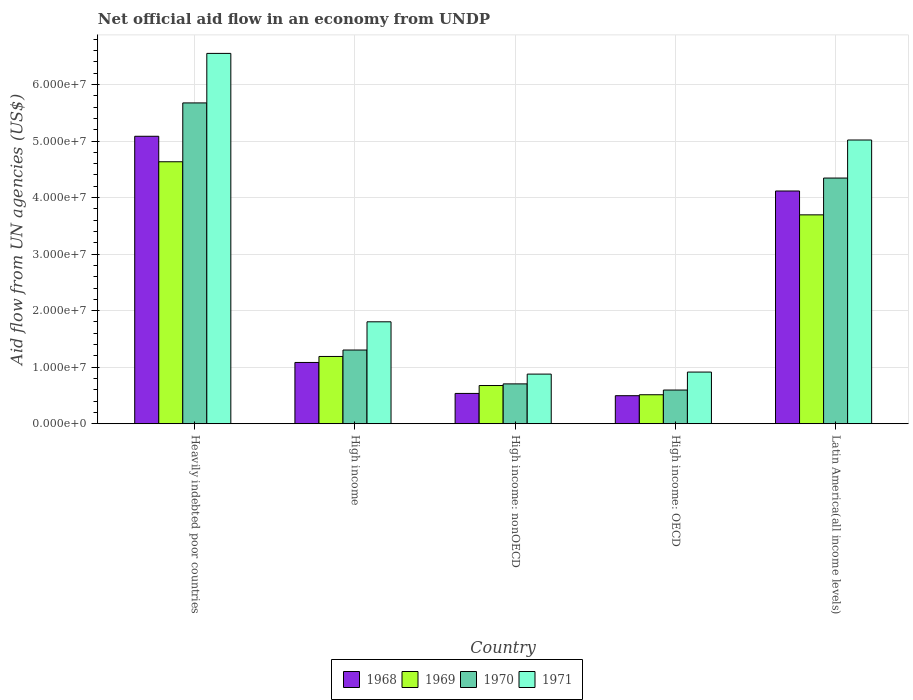How many different coloured bars are there?
Provide a short and direct response. 4. Are the number of bars per tick equal to the number of legend labels?
Offer a terse response. Yes. How many bars are there on the 4th tick from the left?
Make the answer very short. 4. What is the label of the 3rd group of bars from the left?
Your response must be concise. High income: nonOECD. In how many cases, is the number of bars for a given country not equal to the number of legend labels?
Provide a succinct answer. 0. What is the net official aid flow in 1969 in Heavily indebted poor countries?
Give a very brief answer. 4.63e+07. Across all countries, what is the maximum net official aid flow in 1971?
Give a very brief answer. 6.55e+07. Across all countries, what is the minimum net official aid flow in 1970?
Make the answer very short. 5.96e+06. In which country was the net official aid flow in 1969 maximum?
Your answer should be very brief. Heavily indebted poor countries. In which country was the net official aid flow in 1970 minimum?
Your answer should be compact. High income: OECD. What is the total net official aid flow in 1971 in the graph?
Your response must be concise. 1.52e+08. What is the difference between the net official aid flow in 1969 in Heavily indebted poor countries and that in Latin America(all income levels)?
Your response must be concise. 9.39e+06. What is the difference between the net official aid flow in 1969 in Latin America(all income levels) and the net official aid flow in 1968 in Heavily indebted poor countries?
Your response must be concise. -1.39e+07. What is the average net official aid flow in 1971 per country?
Your answer should be very brief. 3.03e+07. What is the difference between the net official aid flow of/in 1971 and net official aid flow of/in 1969 in Heavily indebted poor countries?
Ensure brevity in your answer.  1.92e+07. In how many countries, is the net official aid flow in 1968 greater than 42000000 US$?
Offer a very short reply. 1. What is the ratio of the net official aid flow in 1971 in High income to that in High income: OECD?
Make the answer very short. 1.97. What is the difference between the highest and the second highest net official aid flow in 1969?
Keep it short and to the point. 3.44e+07. What is the difference between the highest and the lowest net official aid flow in 1970?
Provide a succinct answer. 5.08e+07. Is the sum of the net official aid flow in 1968 in High income: nonOECD and Latin America(all income levels) greater than the maximum net official aid flow in 1969 across all countries?
Your answer should be very brief. Yes. Is it the case that in every country, the sum of the net official aid flow in 1969 and net official aid flow in 1971 is greater than the sum of net official aid flow in 1970 and net official aid flow in 1968?
Give a very brief answer. No. What does the 1st bar from the left in High income represents?
Your answer should be very brief. 1968. What does the 4th bar from the right in Latin America(all income levels) represents?
Provide a short and direct response. 1968. How many bars are there?
Provide a succinct answer. 20. What is the difference between two consecutive major ticks on the Y-axis?
Give a very brief answer. 1.00e+07. Where does the legend appear in the graph?
Provide a short and direct response. Bottom center. What is the title of the graph?
Your answer should be compact. Net official aid flow in an economy from UNDP. What is the label or title of the X-axis?
Provide a short and direct response. Country. What is the label or title of the Y-axis?
Offer a terse response. Aid flow from UN agencies (US$). What is the Aid flow from UN agencies (US$) of 1968 in Heavily indebted poor countries?
Your answer should be very brief. 5.08e+07. What is the Aid flow from UN agencies (US$) in 1969 in Heavily indebted poor countries?
Make the answer very short. 4.63e+07. What is the Aid flow from UN agencies (US$) in 1970 in Heavily indebted poor countries?
Your response must be concise. 5.68e+07. What is the Aid flow from UN agencies (US$) in 1971 in Heavily indebted poor countries?
Give a very brief answer. 6.55e+07. What is the Aid flow from UN agencies (US$) of 1968 in High income?
Ensure brevity in your answer.  1.08e+07. What is the Aid flow from UN agencies (US$) of 1969 in High income?
Offer a very short reply. 1.19e+07. What is the Aid flow from UN agencies (US$) in 1970 in High income?
Your answer should be very brief. 1.30e+07. What is the Aid flow from UN agencies (US$) in 1971 in High income?
Provide a succinct answer. 1.80e+07. What is the Aid flow from UN agencies (US$) of 1968 in High income: nonOECD?
Ensure brevity in your answer.  5.36e+06. What is the Aid flow from UN agencies (US$) in 1969 in High income: nonOECD?
Keep it short and to the point. 6.76e+06. What is the Aid flow from UN agencies (US$) of 1970 in High income: nonOECD?
Your answer should be very brief. 7.05e+06. What is the Aid flow from UN agencies (US$) of 1971 in High income: nonOECD?
Your response must be concise. 8.78e+06. What is the Aid flow from UN agencies (US$) in 1968 in High income: OECD?
Keep it short and to the point. 4.96e+06. What is the Aid flow from UN agencies (US$) of 1969 in High income: OECD?
Ensure brevity in your answer.  5.13e+06. What is the Aid flow from UN agencies (US$) of 1970 in High income: OECD?
Offer a terse response. 5.96e+06. What is the Aid flow from UN agencies (US$) of 1971 in High income: OECD?
Provide a short and direct response. 9.14e+06. What is the Aid flow from UN agencies (US$) of 1968 in Latin America(all income levels)?
Give a very brief answer. 4.12e+07. What is the Aid flow from UN agencies (US$) in 1969 in Latin America(all income levels)?
Provide a short and direct response. 3.70e+07. What is the Aid flow from UN agencies (US$) of 1970 in Latin America(all income levels)?
Keep it short and to the point. 4.35e+07. What is the Aid flow from UN agencies (US$) of 1971 in Latin America(all income levels)?
Your response must be concise. 5.02e+07. Across all countries, what is the maximum Aid flow from UN agencies (US$) of 1968?
Keep it short and to the point. 5.08e+07. Across all countries, what is the maximum Aid flow from UN agencies (US$) in 1969?
Give a very brief answer. 4.63e+07. Across all countries, what is the maximum Aid flow from UN agencies (US$) in 1970?
Your answer should be very brief. 5.68e+07. Across all countries, what is the maximum Aid flow from UN agencies (US$) of 1971?
Your answer should be compact. 6.55e+07. Across all countries, what is the minimum Aid flow from UN agencies (US$) of 1968?
Ensure brevity in your answer.  4.96e+06. Across all countries, what is the minimum Aid flow from UN agencies (US$) of 1969?
Your response must be concise. 5.13e+06. Across all countries, what is the minimum Aid flow from UN agencies (US$) of 1970?
Your answer should be very brief. 5.96e+06. Across all countries, what is the minimum Aid flow from UN agencies (US$) in 1971?
Give a very brief answer. 8.78e+06. What is the total Aid flow from UN agencies (US$) of 1968 in the graph?
Your answer should be compact. 1.13e+08. What is the total Aid flow from UN agencies (US$) of 1969 in the graph?
Provide a succinct answer. 1.07e+08. What is the total Aid flow from UN agencies (US$) in 1970 in the graph?
Keep it short and to the point. 1.26e+08. What is the total Aid flow from UN agencies (US$) in 1971 in the graph?
Ensure brevity in your answer.  1.52e+08. What is the difference between the Aid flow from UN agencies (US$) in 1968 in Heavily indebted poor countries and that in High income?
Keep it short and to the point. 4.00e+07. What is the difference between the Aid flow from UN agencies (US$) of 1969 in Heavily indebted poor countries and that in High income?
Give a very brief answer. 3.44e+07. What is the difference between the Aid flow from UN agencies (US$) in 1970 in Heavily indebted poor countries and that in High income?
Provide a succinct answer. 4.37e+07. What is the difference between the Aid flow from UN agencies (US$) of 1971 in Heavily indebted poor countries and that in High income?
Your response must be concise. 4.75e+07. What is the difference between the Aid flow from UN agencies (US$) of 1968 in Heavily indebted poor countries and that in High income: nonOECD?
Your answer should be very brief. 4.55e+07. What is the difference between the Aid flow from UN agencies (US$) in 1969 in Heavily indebted poor countries and that in High income: nonOECD?
Make the answer very short. 3.96e+07. What is the difference between the Aid flow from UN agencies (US$) in 1970 in Heavily indebted poor countries and that in High income: nonOECD?
Offer a very short reply. 4.97e+07. What is the difference between the Aid flow from UN agencies (US$) of 1971 in Heavily indebted poor countries and that in High income: nonOECD?
Make the answer very short. 5.67e+07. What is the difference between the Aid flow from UN agencies (US$) of 1968 in Heavily indebted poor countries and that in High income: OECD?
Your response must be concise. 4.59e+07. What is the difference between the Aid flow from UN agencies (US$) of 1969 in Heavily indebted poor countries and that in High income: OECD?
Offer a terse response. 4.12e+07. What is the difference between the Aid flow from UN agencies (US$) in 1970 in Heavily indebted poor countries and that in High income: OECD?
Your answer should be compact. 5.08e+07. What is the difference between the Aid flow from UN agencies (US$) in 1971 in Heavily indebted poor countries and that in High income: OECD?
Your answer should be very brief. 5.64e+07. What is the difference between the Aid flow from UN agencies (US$) of 1968 in Heavily indebted poor countries and that in Latin America(all income levels)?
Offer a terse response. 9.68e+06. What is the difference between the Aid flow from UN agencies (US$) of 1969 in Heavily indebted poor countries and that in Latin America(all income levels)?
Keep it short and to the point. 9.39e+06. What is the difference between the Aid flow from UN agencies (US$) in 1970 in Heavily indebted poor countries and that in Latin America(all income levels)?
Keep it short and to the point. 1.33e+07. What is the difference between the Aid flow from UN agencies (US$) of 1971 in Heavily indebted poor countries and that in Latin America(all income levels)?
Ensure brevity in your answer.  1.53e+07. What is the difference between the Aid flow from UN agencies (US$) in 1968 in High income and that in High income: nonOECD?
Make the answer very short. 5.48e+06. What is the difference between the Aid flow from UN agencies (US$) in 1969 in High income and that in High income: nonOECD?
Offer a very short reply. 5.14e+06. What is the difference between the Aid flow from UN agencies (US$) of 1970 in High income and that in High income: nonOECD?
Your answer should be compact. 5.99e+06. What is the difference between the Aid flow from UN agencies (US$) in 1971 in High income and that in High income: nonOECD?
Provide a short and direct response. 9.25e+06. What is the difference between the Aid flow from UN agencies (US$) in 1968 in High income and that in High income: OECD?
Your answer should be compact. 5.88e+06. What is the difference between the Aid flow from UN agencies (US$) of 1969 in High income and that in High income: OECD?
Make the answer very short. 6.77e+06. What is the difference between the Aid flow from UN agencies (US$) in 1970 in High income and that in High income: OECD?
Give a very brief answer. 7.08e+06. What is the difference between the Aid flow from UN agencies (US$) of 1971 in High income and that in High income: OECD?
Your response must be concise. 8.89e+06. What is the difference between the Aid flow from UN agencies (US$) of 1968 in High income and that in Latin America(all income levels)?
Provide a short and direct response. -3.03e+07. What is the difference between the Aid flow from UN agencies (US$) of 1969 in High income and that in Latin America(all income levels)?
Keep it short and to the point. -2.50e+07. What is the difference between the Aid flow from UN agencies (US$) in 1970 in High income and that in Latin America(all income levels)?
Offer a terse response. -3.04e+07. What is the difference between the Aid flow from UN agencies (US$) in 1971 in High income and that in Latin America(all income levels)?
Keep it short and to the point. -3.22e+07. What is the difference between the Aid flow from UN agencies (US$) of 1969 in High income: nonOECD and that in High income: OECD?
Provide a succinct answer. 1.63e+06. What is the difference between the Aid flow from UN agencies (US$) of 1970 in High income: nonOECD and that in High income: OECD?
Your answer should be very brief. 1.09e+06. What is the difference between the Aid flow from UN agencies (US$) of 1971 in High income: nonOECD and that in High income: OECD?
Offer a very short reply. -3.60e+05. What is the difference between the Aid flow from UN agencies (US$) in 1968 in High income: nonOECD and that in Latin America(all income levels)?
Your answer should be compact. -3.58e+07. What is the difference between the Aid flow from UN agencies (US$) in 1969 in High income: nonOECD and that in Latin America(all income levels)?
Keep it short and to the point. -3.02e+07. What is the difference between the Aid flow from UN agencies (US$) in 1970 in High income: nonOECD and that in Latin America(all income levels)?
Give a very brief answer. -3.64e+07. What is the difference between the Aid flow from UN agencies (US$) in 1971 in High income: nonOECD and that in Latin America(all income levels)?
Offer a terse response. -4.14e+07. What is the difference between the Aid flow from UN agencies (US$) in 1968 in High income: OECD and that in Latin America(all income levels)?
Offer a terse response. -3.62e+07. What is the difference between the Aid flow from UN agencies (US$) of 1969 in High income: OECD and that in Latin America(all income levels)?
Your answer should be very brief. -3.18e+07. What is the difference between the Aid flow from UN agencies (US$) in 1970 in High income: OECD and that in Latin America(all income levels)?
Provide a succinct answer. -3.75e+07. What is the difference between the Aid flow from UN agencies (US$) in 1971 in High income: OECD and that in Latin America(all income levels)?
Your answer should be very brief. -4.10e+07. What is the difference between the Aid flow from UN agencies (US$) of 1968 in Heavily indebted poor countries and the Aid flow from UN agencies (US$) of 1969 in High income?
Provide a short and direct response. 3.90e+07. What is the difference between the Aid flow from UN agencies (US$) of 1968 in Heavily indebted poor countries and the Aid flow from UN agencies (US$) of 1970 in High income?
Keep it short and to the point. 3.78e+07. What is the difference between the Aid flow from UN agencies (US$) of 1968 in Heavily indebted poor countries and the Aid flow from UN agencies (US$) of 1971 in High income?
Keep it short and to the point. 3.28e+07. What is the difference between the Aid flow from UN agencies (US$) of 1969 in Heavily indebted poor countries and the Aid flow from UN agencies (US$) of 1970 in High income?
Your answer should be compact. 3.33e+07. What is the difference between the Aid flow from UN agencies (US$) of 1969 in Heavily indebted poor countries and the Aid flow from UN agencies (US$) of 1971 in High income?
Your answer should be compact. 2.83e+07. What is the difference between the Aid flow from UN agencies (US$) in 1970 in Heavily indebted poor countries and the Aid flow from UN agencies (US$) in 1971 in High income?
Offer a terse response. 3.87e+07. What is the difference between the Aid flow from UN agencies (US$) of 1968 in Heavily indebted poor countries and the Aid flow from UN agencies (US$) of 1969 in High income: nonOECD?
Ensure brevity in your answer.  4.41e+07. What is the difference between the Aid flow from UN agencies (US$) in 1968 in Heavily indebted poor countries and the Aid flow from UN agencies (US$) in 1970 in High income: nonOECD?
Keep it short and to the point. 4.38e+07. What is the difference between the Aid flow from UN agencies (US$) in 1968 in Heavily indebted poor countries and the Aid flow from UN agencies (US$) in 1971 in High income: nonOECD?
Your answer should be very brief. 4.21e+07. What is the difference between the Aid flow from UN agencies (US$) of 1969 in Heavily indebted poor countries and the Aid flow from UN agencies (US$) of 1970 in High income: nonOECD?
Ensure brevity in your answer.  3.93e+07. What is the difference between the Aid flow from UN agencies (US$) in 1969 in Heavily indebted poor countries and the Aid flow from UN agencies (US$) in 1971 in High income: nonOECD?
Your answer should be very brief. 3.76e+07. What is the difference between the Aid flow from UN agencies (US$) of 1970 in Heavily indebted poor countries and the Aid flow from UN agencies (US$) of 1971 in High income: nonOECD?
Your answer should be very brief. 4.80e+07. What is the difference between the Aid flow from UN agencies (US$) in 1968 in Heavily indebted poor countries and the Aid flow from UN agencies (US$) in 1969 in High income: OECD?
Offer a terse response. 4.57e+07. What is the difference between the Aid flow from UN agencies (US$) of 1968 in Heavily indebted poor countries and the Aid flow from UN agencies (US$) of 1970 in High income: OECD?
Provide a short and direct response. 4.49e+07. What is the difference between the Aid flow from UN agencies (US$) in 1968 in Heavily indebted poor countries and the Aid flow from UN agencies (US$) in 1971 in High income: OECD?
Offer a very short reply. 4.17e+07. What is the difference between the Aid flow from UN agencies (US$) of 1969 in Heavily indebted poor countries and the Aid flow from UN agencies (US$) of 1970 in High income: OECD?
Provide a short and direct response. 4.04e+07. What is the difference between the Aid flow from UN agencies (US$) in 1969 in Heavily indebted poor countries and the Aid flow from UN agencies (US$) in 1971 in High income: OECD?
Make the answer very short. 3.72e+07. What is the difference between the Aid flow from UN agencies (US$) of 1970 in Heavily indebted poor countries and the Aid flow from UN agencies (US$) of 1971 in High income: OECD?
Your response must be concise. 4.76e+07. What is the difference between the Aid flow from UN agencies (US$) in 1968 in Heavily indebted poor countries and the Aid flow from UN agencies (US$) in 1969 in Latin America(all income levels)?
Your answer should be very brief. 1.39e+07. What is the difference between the Aid flow from UN agencies (US$) of 1968 in Heavily indebted poor countries and the Aid flow from UN agencies (US$) of 1970 in Latin America(all income levels)?
Provide a short and direct response. 7.39e+06. What is the difference between the Aid flow from UN agencies (US$) in 1969 in Heavily indebted poor countries and the Aid flow from UN agencies (US$) in 1970 in Latin America(all income levels)?
Keep it short and to the point. 2.88e+06. What is the difference between the Aid flow from UN agencies (US$) of 1969 in Heavily indebted poor countries and the Aid flow from UN agencies (US$) of 1971 in Latin America(all income levels)?
Keep it short and to the point. -3.85e+06. What is the difference between the Aid flow from UN agencies (US$) of 1970 in Heavily indebted poor countries and the Aid flow from UN agencies (US$) of 1971 in Latin America(all income levels)?
Your response must be concise. 6.56e+06. What is the difference between the Aid flow from UN agencies (US$) in 1968 in High income and the Aid flow from UN agencies (US$) in 1969 in High income: nonOECD?
Your response must be concise. 4.08e+06. What is the difference between the Aid flow from UN agencies (US$) of 1968 in High income and the Aid flow from UN agencies (US$) of 1970 in High income: nonOECD?
Make the answer very short. 3.79e+06. What is the difference between the Aid flow from UN agencies (US$) in 1968 in High income and the Aid flow from UN agencies (US$) in 1971 in High income: nonOECD?
Your answer should be compact. 2.06e+06. What is the difference between the Aid flow from UN agencies (US$) of 1969 in High income and the Aid flow from UN agencies (US$) of 1970 in High income: nonOECD?
Make the answer very short. 4.85e+06. What is the difference between the Aid flow from UN agencies (US$) in 1969 in High income and the Aid flow from UN agencies (US$) in 1971 in High income: nonOECD?
Ensure brevity in your answer.  3.12e+06. What is the difference between the Aid flow from UN agencies (US$) of 1970 in High income and the Aid flow from UN agencies (US$) of 1971 in High income: nonOECD?
Make the answer very short. 4.26e+06. What is the difference between the Aid flow from UN agencies (US$) of 1968 in High income and the Aid flow from UN agencies (US$) of 1969 in High income: OECD?
Provide a succinct answer. 5.71e+06. What is the difference between the Aid flow from UN agencies (US$) of 1968 in High income and the Aid flow from UN agencies (US$) of 1970 in High income: OECD?
Provide a short and direct response. 4.88e+06. What is the difference between the Aid flow from UN agencies (US$) of 1968 in High income and the Aid flow from UN agencies (US$) of 1971 in High income: OECD?
Your answer should be compact. 1.70e+06. What is the difference between the Aid flow from UN agencies (US$) of 1969 in High income and the Aid flow from UN agencies (US$) of 1970 in High income: OECD?
Make the answer very short. 5.94e+06. What is the difference between the Aid flow from UN agencies (US$) in 1969 in High income and the Aid flow from UN agencies (US$) in 1971 in High income: OECD?
Offer a very short reply. 2.76e+06. What is the difference between the Aid flow from UN agencies (US$) of 1970 in High income and the Aid flow from UN agencies (US$) of 1971 in High income: OECD?
Offer a very short reply. 3.90e+06. What is the difference between the Aid flow from UN agencies (US$) in 1968 in High income and the Aid flow from UN agencies (US$) in 1969 in Latin America(all income levels)?
Keep it short and to the point. -2.61e+07. What is the difference between the Aid flow from UN agencies (US$) in 1968 in High income and the Aid flow from UN agencies (US$) in 1970 in Latin America(all income levels)?
Offer a very short reply. -3.26e+07. What is the difference between the Aid flow from UN agencies (US$) of 1968 in High income and the Aid flow from UN agencies (US$) of 1971 in Latin America(all income levels)?
Your response must be concise. -3.94e+07. What is the difference between the Aid flow from UN agencies (US$) of 1969 in High income and the Aid flow from UN agencies (US$) of 1970 in Latin America(all income levels)?
Offer a terse response. -3.16e+07. What is the difference between the Aid flow from UN agencies (US$) in 1969 in High income and the Aid flow from UN agencies (US$) in 1971 in Latin America(all income levels)?
Give a very brief answer. -3.83e+07. What is the difference between the Aid flow from UN agencies (US$) in 1970 in High income and the Aid flow from UN agencies (US$) in 1971 in Latin America(all income levels)?
Ensure brevity in your answer.  -3.72e+07. What is the difference between the Aid flow from UN agencies (US$) in 1968 in High income: nonOECD and the Aid flow from UN agencies (US$) in 1970 in High income: OECD?
Offer a terse response. -6.00e+05. What is the difference between the Aid flow from UN agencies (US$) of 1968 in High income: nonOECD and the Aid flow from UN agencies (US$) of 1971 in High income: OECD?
Give a very brief answer. -3.78e+06. What is the difference between the Aid flow from UN agencies (US$) in 1969 in High income: nonOECD and the Aid flow from UN agencies (US$) in 1970 in High income: OECD?
Your response must be concise. 8.00e+05. What is the difference between the Aid flow from UN agencies (US$) in 1969 in High income: nonOECD and the Aid flow from UN agencies (US$) in 1971 in High income: OECD?
Your answer should be compact. -2.38e+06. What is the difference between the Aid flow from UN agencies (US$) in 1970 in High income: nonOECD and the Aid flow from UN agencies (US$) in 1971 in High income: OECD?
Offer a terse response. -2.09e+06. What is the difference between the Aid flow from UN agencies (US$) of 1968 in High income: nonOECD and the Aid flow from UN agencies (US$) of 1969 in Latin America(all income levels)?
Offer a terse response. -3.16e+07. What is the difference between the Aid flow from UN agencies (US$) in 1968 in High income: nonOECD and the Aid flow from UN agencies (US$) in 1970 in Latin America(all income levels)?
Keep it short and to the point. -3.81e+07. What is the difference between the Aid flow from UN agencies (US$) in 1968 in High income: nonOECD and the Aid flow from UN agencies (US$) in 1971 in Latin America(all income levels)?
Offer a terse response. -4.48e+07. What is the difference between the Aid flow from UN agencies (US$) of 1969 in High income: nonOECD and the Aid flow from UN agencies (US$) of 1970 in Latin America(all income levels)?
Your answer should be very brief. -3.67e+07. What is the difference between the Aid flow from UN agencies (US$) of 1969 in High income: nonOECD and the Aid flow from UN agencies (US$) of 1971 in Latin America(all income levels)?
Offer a terse response. -4.34e+07. What is the difference between the Aid flow from UN agencies (US$) of 1970 in High income: nonOECD and the Aid flow from UN agencies (US$) of 1971 in Latin America(all income levels)?
Give a very brief answer. -4.31e+07. What is the difference between the Aid flow from UN agencies (US$) of 1968 in High income: OECD and the Aid flow from UN agencies (US$) of 1969 in Latin America(all income levels)?
Offer a terse response. -3.20e+07. What is the difference between the Aid flow from UN agencies (US$) of 1968 in High income: OECD and the Aid flow from UN agencies (US$) of 1970 in Latin America(all income levels)?
Offer a very short reply. -3.85e+07. What is the difference between the Aid flow from UN agencies (US$) in 1968 in High income: OECD and the Aid flow from UN agencies (US$) in 1971 in Latin America(all income levels)?
Your response must be concise. -4.52e+07. What is the difference between the Aid flow from UN agencies (US$) of 1969 in High income: OECD and the Aid flow from UN agencies (US$) of 1970 in Latin America(all income levels)?
Make the answer very short. -3.83e+07. What is the difference between the Aid flow from UN agencies (US$) of 1969 in High income: OECD and the Aid flow from UN agencies (US$) of 1971 in Latin America(all income levels)?
Offer a terse response. -4.51e+07. What is the difference between the Aid flow from UN agencies (US$) in 1970 in High income: OECD and the Aid flow from UN agencies (US$) in 1971 in Latin America(all income levels)?
Offer a very short reply. -4.42e+07. What is the average Aid flow from UN agencies (US$) in 1968 per country?
Provide a succinct answer. 2.26e+07. What is the average Aid flow from UN agencies (US$) of 1969 per country?
Ensure brevity in your answer.  2.14e+07. What is the average Aid flow from UN agencies (US$) in 1970 per country?
Provide a short and direct response. 2.53e+07. What is the average Aid flow from UN agencies (US$) of 1971 per country?
Your response must be concise. 3.03e+07. What is the difference between the Aid flow from UN agencies (US$) in 1968 and Aid flow from UN agencies (US$) in 1969 in Heavily indebted poor countries?
Make the answer very short. 4.51e+06. What is the difference between the Aid flow from UN agencies (US$) in 1968 and Aid flow from UN agencies (US$) in 1970 in Heavily indebted poor countries?
Offer a very short reply. -5.90e+06. What is the difference between the Aid flow from UN agencies (US$) in 1968 and Aid flow from UN agencies (US$) in 1971 in Heavily indebted poor countries?
Your response must be concise. -1.47e+07. What is the difference between the Aid flow from UN agencies (US$) in 1969 and Aid flow from UN agencies (US$) in 1970 in Heavily indebted poor countries?
Your answer should be very brief. -1.04e+07. What is the difference between the Aid flow from UN agencies (US$) in 1969 and Aid flow from UN agencies (US$) in 1971 in Heavily indebted poor countries?
Provide a succinct answer. -1.92e+07. What is the difference between the Aid flow from UN agencies (US$) of 1970 and Aid flow from UN agencies (US$) of 1971 in Heavily indebted poor countries?
Make the answer very short. -8.76e+06. What is the difference between the Aid flow from UN agencies (US$) in 1968 and Aid flow from UN agencies (US$) in 1969 in High income?
Offer a very short reply. -1.06e+06. What is the difference between the Aid flow from UN agencies (US$) of 1968 and Aid flow from UN agencies (US$) of 1970 in High income?
Offer a very short reply. -2.20e+06. What is the difference between the Aid flow from UN agencies (US$) in 1968 and Aid flow from UN agencies (US$) in 1971 in High income?
Your answer should be compact. -7.19e+06. What is the difference between the Aid flow from UN agencies (US$) in 1969 and Aid flow from UN agencies (US$) in 1970 in High income?
Give a very brief answer. -1.14e+06. What is the difference between the Aid flow from UN agencies (US$) in 1969 and Aid flow from UN agencies (US$) in 1971 in High income?
Offer a very short reply. -6.13e+06. What is the difference between the Aid flow from UN agencies (US$) in 1970 and Aid flow from UN agencies (US$) in 1971 in High income?
Provide a succinct answer. -4.99e+06. What is the difference between the Aid flow from UN agencies (US$) of 1968 and Aid flow from UN agencies (US$) of 1969 in High income: nonOECD?
Your answer should be very brief. -1.40e+06. What is the difference between the Aid flow from UN agencies (US$) in 1968 and Aid flow from UN agencies (US$) in 1970 in High income: nonOECD?
Provide a short and direct response. -1.69e+06. What is the difference between the Aid flow from UN agencies (US$) of 1968 and Aid flow from UN agencies (US$) of 1971 in High income: nonOECD?
Offer a terse response. -3.42e+06. What is the difference between the Aid flow from UN agencies (US$) of 1969 and Aid flow from UN agencies (US$) of 1970 in High income: nonOECD?
Keep it short and to the point. -2.90e+05. What is the difference between the Aid flow from UN agencies (US$) in 1969 and Aid flow from UN agencies (US$) in 1971 in High income: nonOECD?
Ensure brevity in your answer.  -2.02e+06. What is the difference between the Aid flow from UN agencies (US$) in 1970 and Aid flow from UN agencies (US$) in 1971 in High income: nonOECD?
Make the answer very short. -1.73e+06. What is the difference between the Aid flow from UN agencies (US$) of 1968 and Aid flow from UN agencies (US$) of 1969 in High income: OECD?
Offer a very short reply. -1.70e+05. What is the difference between the Aid flow from UN agencies (US$) of 1968 and Aid flow from UN agencies (US$) of 1971 in High income: OECD?
Your response must be concise. -4.18e+06. What is the difference between the Aid flow from UN agencies (US$) in 1969 and Aid flow from UN agencies (US$) in 1970 in High income: OECD?
Offer a terse response. -8.30e+05. What is the difference between the Aid flow from UN agencies (US$) in 1969 and Aid flow from UN agencies (US$) in 1971 in High income: OECD?
Your answer should be compact. -4.01e+06. What is the difference between the Aid flow from UN agencies (US$) in 1970 and Aid flow from UN agencies (US$) in 1971 in High income: OECD?
Your response must be concise. -3.18e+06. What is the difference between the Aid flow from UN agencies (US$) in 1968 and Aid flow from UN agencies (US$) in 1969 in Latin America(all income levels)?
Provide a short and direct response. 4.22e+06. What is the difference between the Aid flow from UN agencies (US$) of 1968 and Aid flow from UN agencies (US$) of 1970 in Latin America(all income levels)?
Keep it short and to the point. -2.29e+06. What is the difference between the Aid flow from UN agencies (US$) of 1968 and Aid flow from UN agencies (US$) of 1971 in Latin America(all income levels)?
Offer a terse response. -9.02e+06. What is the difference between the Aid flow from UN agencies (US$) in 1969 and Aid flow from UN agencies (US$) in 1970 in Latin America(all income levels)?
Provide a succinct answer. -6.51e+06. What is the difference between the Aid flow from UN agencies (US$) of 1969 and Aid flow from UN agencies (US$) of 1971 in Latin America(all income levels)?
Your answer should be compact. -1.32e+07. What is the difference between the Aid flow from UN agencies (US$) of 1970 and Aid flow from UN agencies (US$) of 1971 in Latin America(all income levels)?
Give a very brief answer. -6.73e+06. What is the ratio of the Aid flow from UN agencies (US$) of 1968 in Heavily indebted poor countries to that in High income?
Your response must be concise. 4.69. What is the ratio of the Aid flow from UN agencies (US$) of 1969 in Heavily indebted poor countries to that in High income?
Ensure brevity in your answer.  3.89. What is the ratio of the Aid flow from UN agencies (US$) of 1970 in Heavily indebted poor countries to that in High income?
Your answer should be very brief. 4.35. What is the ratio of the Aid flow from UN agencies (US$) in 1971 in Heavily indebted poor countries to that in High income?
Give a very brief answer. 3.63. What is the ratio of the Aid flow from UN agencies (US$) of 1968 in Heavily indebted poor countries to that in High income: nonOECD?
Provide a short and direct response. 9.49. What is the ratio of the Aid flow from UN agencies (US$) in 1969 in Heavily indebted poor countries to that in High income: nonOECD?
Provide a short and direct response. 6.86. What is the ratio of the Aid flow from UN agencies (US$) of 1970 in Heavily indebted poor countries to that in High income: nonOECD?
Provide a succinct answer. 8.05. What is the ratio of the Aid flow from UN agencies (US$) of 1971 in Heavily indebted poor countries to that in High income: nonOECD?
Ensure brevity in your answer.  7.46. What is the ratio of the Aid flow from UN agencies (US$) of 1968 in Heavily indebted poor countries to that in High income: OECD?
Ensure brevity in your answer.  10.25. What is the ratio of the Aid flow from UN agencies (US$) of 1969 in Heavily indebted poor countries to that in High income: OECD?
Provide a succinct answer. 9.03. What is the ratio of the Aid flow from UN agencies (US$) of 1970 in Heavily indebted poor countries to that in High income: OECD?
Ensure brevity in your answer.  9.52. What is the ratio of the Aid flow from UN agencies (US$) in 1971 in Heavily indebted poor countries to that in High income: OECD?
Make the answer very short. 7.17. What is the ratio of the Aid flow from UN agencies (US$) in 1968 in Heavily indebted poor countries to that in Latin America(all income levels)?
Keep it short and to the point. 1.24. What is the ratio of the Aid flow from UN agencies (US$) of 1969 in Heavily indebted poor countries to that in Latin America(all income levels)?
Ensure brevity in your answer.  1.25. What is the ratio of the Aid flow from UN agencies (US$) in 1970 in Heavily indebted poor countries to that in Latin America(all income levels)?
Keep it short and to the point. 1.31. What is the ratio of the Aid flow from UN agencies (US$) in 1971 in Heavily indebted poor countries to that in Latin America(all income levels)?
Give a very brief answer. 1.31. What is the ratio of the Aid flow from UN agencies (US$) in 1968 in High income to that in High income: nonOECD?
Make the answer very short. 2.02. What is the ratio of the Aid flow from UN agencies (US$) of 1969 in High income to that in High income: nonOECD?
Keep it short and to the point. 1.76. What is the ratio of the Aid flow from UN agencies (US$) in 1970 in High income to that in High income: nonOECD?
Offer a terse response. 1.85. What is the ratio of the Aid flow from UN agencies (US$) in 1971 in High income to that in High income: nonOECD?
Offer a terse response. 2.05. What is the ratio of the Aid flow from UN agencies (US$) of 1968 in High income to that in High income: OECD?
Make the answer very short. 2.19. What is the ratio of the Aid flow from UN agencies (US$) in 1969 in High income to that in High income: OECD?
Provide a short and direct response. 2.32. What is the ratio of the Aid flow from UN agencies (US$) in 1970 in High income to that in High income: OECD?
Keep it short and to the point. 2.19. What is the ratio of the Aid flow from UN agencies (US$) in 1971 in High income to that in High income: OECD?
Offer a very short reply. 1.97. What is the ratio of the Aid flow from UN agencies (US$) of 1968 in High income to that in Latin America(all income levels)?
Your answer should be very brief. 0.26. What is the ratio of the Aid flow from UN agencies (US$) of 1969 in High income to that in Latin America(all income levels)?
Give a very brief answer. 0.32. What is the ratio of the Aid flow from UN agencies (US$) of 1971 in High income to that in Latin America(all income levels)?
Offer a very short reply. 0.36. What is the ratio of the Aid flow from UN agencies (US$) in 1968 in High income: nonOECD to that in High income: OECD?
Make the answer very short. 1.08. What is the ratio of the Aid flow from UN agencies (US$) in 1969 in High income: nonOECD to that in High income: OECD?
Keep it short and to the point. 1.32. What is the ratio of the Aid flow from UN agencies (US$) in 1970 in High income: nonOECD to that in High income: OECD?
Offer a very short reply. 1.18. What is the ratio of the Aid flow from UN agencies (US$) of 1971 in High income: nonOECD to that in High income: OECD?
Provide a succinct answer. 0.96. What is the ratio of the Aid flow from UN agencies (US$) in 1968 in High income: nonOECD to that in Latin America(all income levels)?
Give a very brief answer. 0.13. What is the ratio of the Aid flow from UN agencies (US$) of 1969 in High income: nonOECD to that in Latin America(all income levels)?
Provide a succinct answer. 0.18. What is the ratio of the Aid flow from UN agencies (US$) in 1970 in High income: nonOECD to that in Latin America(all income levels)?
Make the answer very short. 0.16. What is the ratio of the Aid flow from UN agencies (US$) of 1971 in High income: nonOECD to that in Latin America(all income levels)?
Provide a succinct answer. 0.17. What is the ratio of the Aid flow from UN agencies (US$) in 1968 in High income: OECD to that in Latin America(all income levels)?
Your answer should be very brief. 0.12. What is the ratio of the Aid flow from UN agencies (US$) in 1969 in High income: OECD to that in Latin America(all income levels)?
Offer a very short reply. 0.14. What is the ratio of the Aid flow from UN agencies (US$) of 1970 in High income: OECD to that in Latin America(all income levels)?
Give a very brief answer. 0.14. What is the ratio of the Aid flow from UN agencies (US$) in 1971 in High income: OECD to that in Latin America(all income levels)?
Make the answer very short. 0.18. What is the difference between the highest and the second highest Aid flow from UN agencies (US$) in 1968?
Give a very brief answer. 9.68e+06. What is the difference between the highest and the second highest Aid flow from UN agencies (US$) of 1969?
Your answer should be compact. 9.39e+06. What is the difference between the highest and the second highest Aid flow from UN agencies (US$) in 1970?
Offer a terse response. 1.33e+07. What is the difference between the highest and the second highest Aid flow from UN agencies (US$) of 1971?
Ensure brevity in your answer.  1.53e+07. What is the difference between the highest and the lowest Aid flow from UN agencies (US$) of 1968?
Keep it short and to the point. 4.59e+07. What is the difference between the highest and the lowest Aid flow from UN agencies (US$) in 1969?
Offer a terse response. 4.12e+07. What is the difference between the highest and the lowest Aid flow from UN agencies (US$) in 1970?
Provide a short and direct response. 5.08e+07. What is the difference between the highest and the lowest Aid flow from UN agencies (US$) in 1971?
Your answer should be very brief. 5.67e+07. 